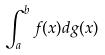Convert formula to latex. <formula><loc_0><loc_0><loc_500><loc_500>\int _ { a } ^ { b } f ( x ) d g ( x )</formula> 